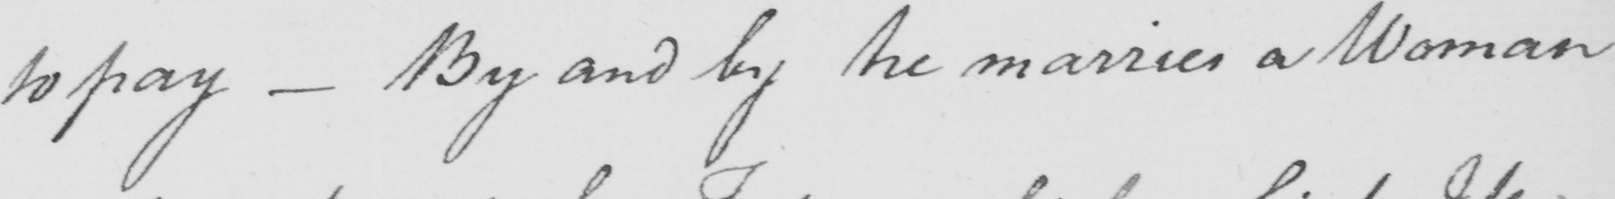What does this handwritten line say? to pay  _  By and by he marries a Woman 